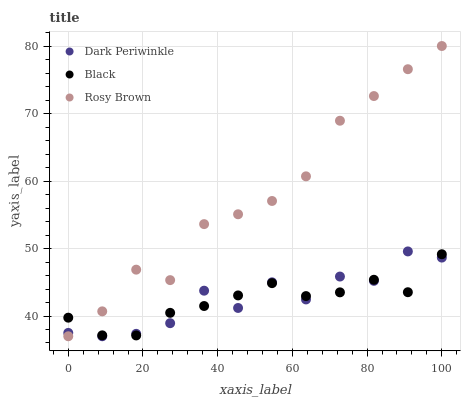Does Black have the minimum area under the curve?
Answer yes or no. Yes. Does Rosy Brown have the maximum area under the curve?
Answer yes or no. Yes. Does Dark Periwinkle have the minimum area under the curve?
Answer yes or no. No. Does Dark Periwinkle have the maximum area under the curve?
Answer yes or no. No. Is Black the smoothest?
Answer yes or no. Yes. Is Dark Periwinkle the roughest?
Answer yes or no. Yes. Is Dark Periwinkle the smoothest?
Answer yes or no. No. Is Black the roughest?
Answer yes or no. No. Does Rosy Brown have the lowest value?
Answer yes or no. Yes. Does Black have the lowest value?
Answer yes or no. No. Does Rosy Brown have the highest value?
Answer yes or no. Yes. Does Dark Periwinkle have the highest value?
Answer yes or no. No. Does Dark Periwinkle intersect Rosy Brown?
Answer yes or no. Yes. Is Dark Periwinkle less than Rosy Brown?
Answer yes or no. No. Is Dark Periwinkle greater than Rosy Brown?
Answer yes or no. No. 